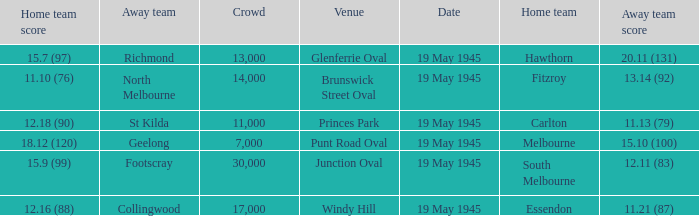Can you give me this table as a dict? {'header': ['Home team score', 'Away team', 'Crowd', 'Venue', 'Date', 'Home team', 'Away team score'], 'rows': [['15.7 (97)', 'Richmond', '13,000', 'Glenferrie Oval', '19 May 1945', 'Hawthorn', '20.11 (131)'], ['11.10 (76)', 'North Melbourne', '14,000', 'Brunswick Street Oval', '19 May 1945', 'Fitzroy', '13.14 (92)'], ['12.18 (90)', 'St Kilda', '11,000', 'Princes Park', '19 May 1945', 'Carlton', '11.13 (79)'], ['18.12 (120)', 'Geelong', '7,000', 'Punt Road Oval', '19 May 1945', 'Melbourne', '15.10 (100)'], ['15.9 (99)', 'Footscray', '30,000', 'Junction Oval', '19 May 1945', 'South Melbourne', '12.11 (83)'], ['12.16 (88)', 'Collingwood', '17,000', 'Windy Hill', '19 May 1945', 'Essendon', '11.21 (87)']]} On which date was Essendon the home team? 19 May 1945. 